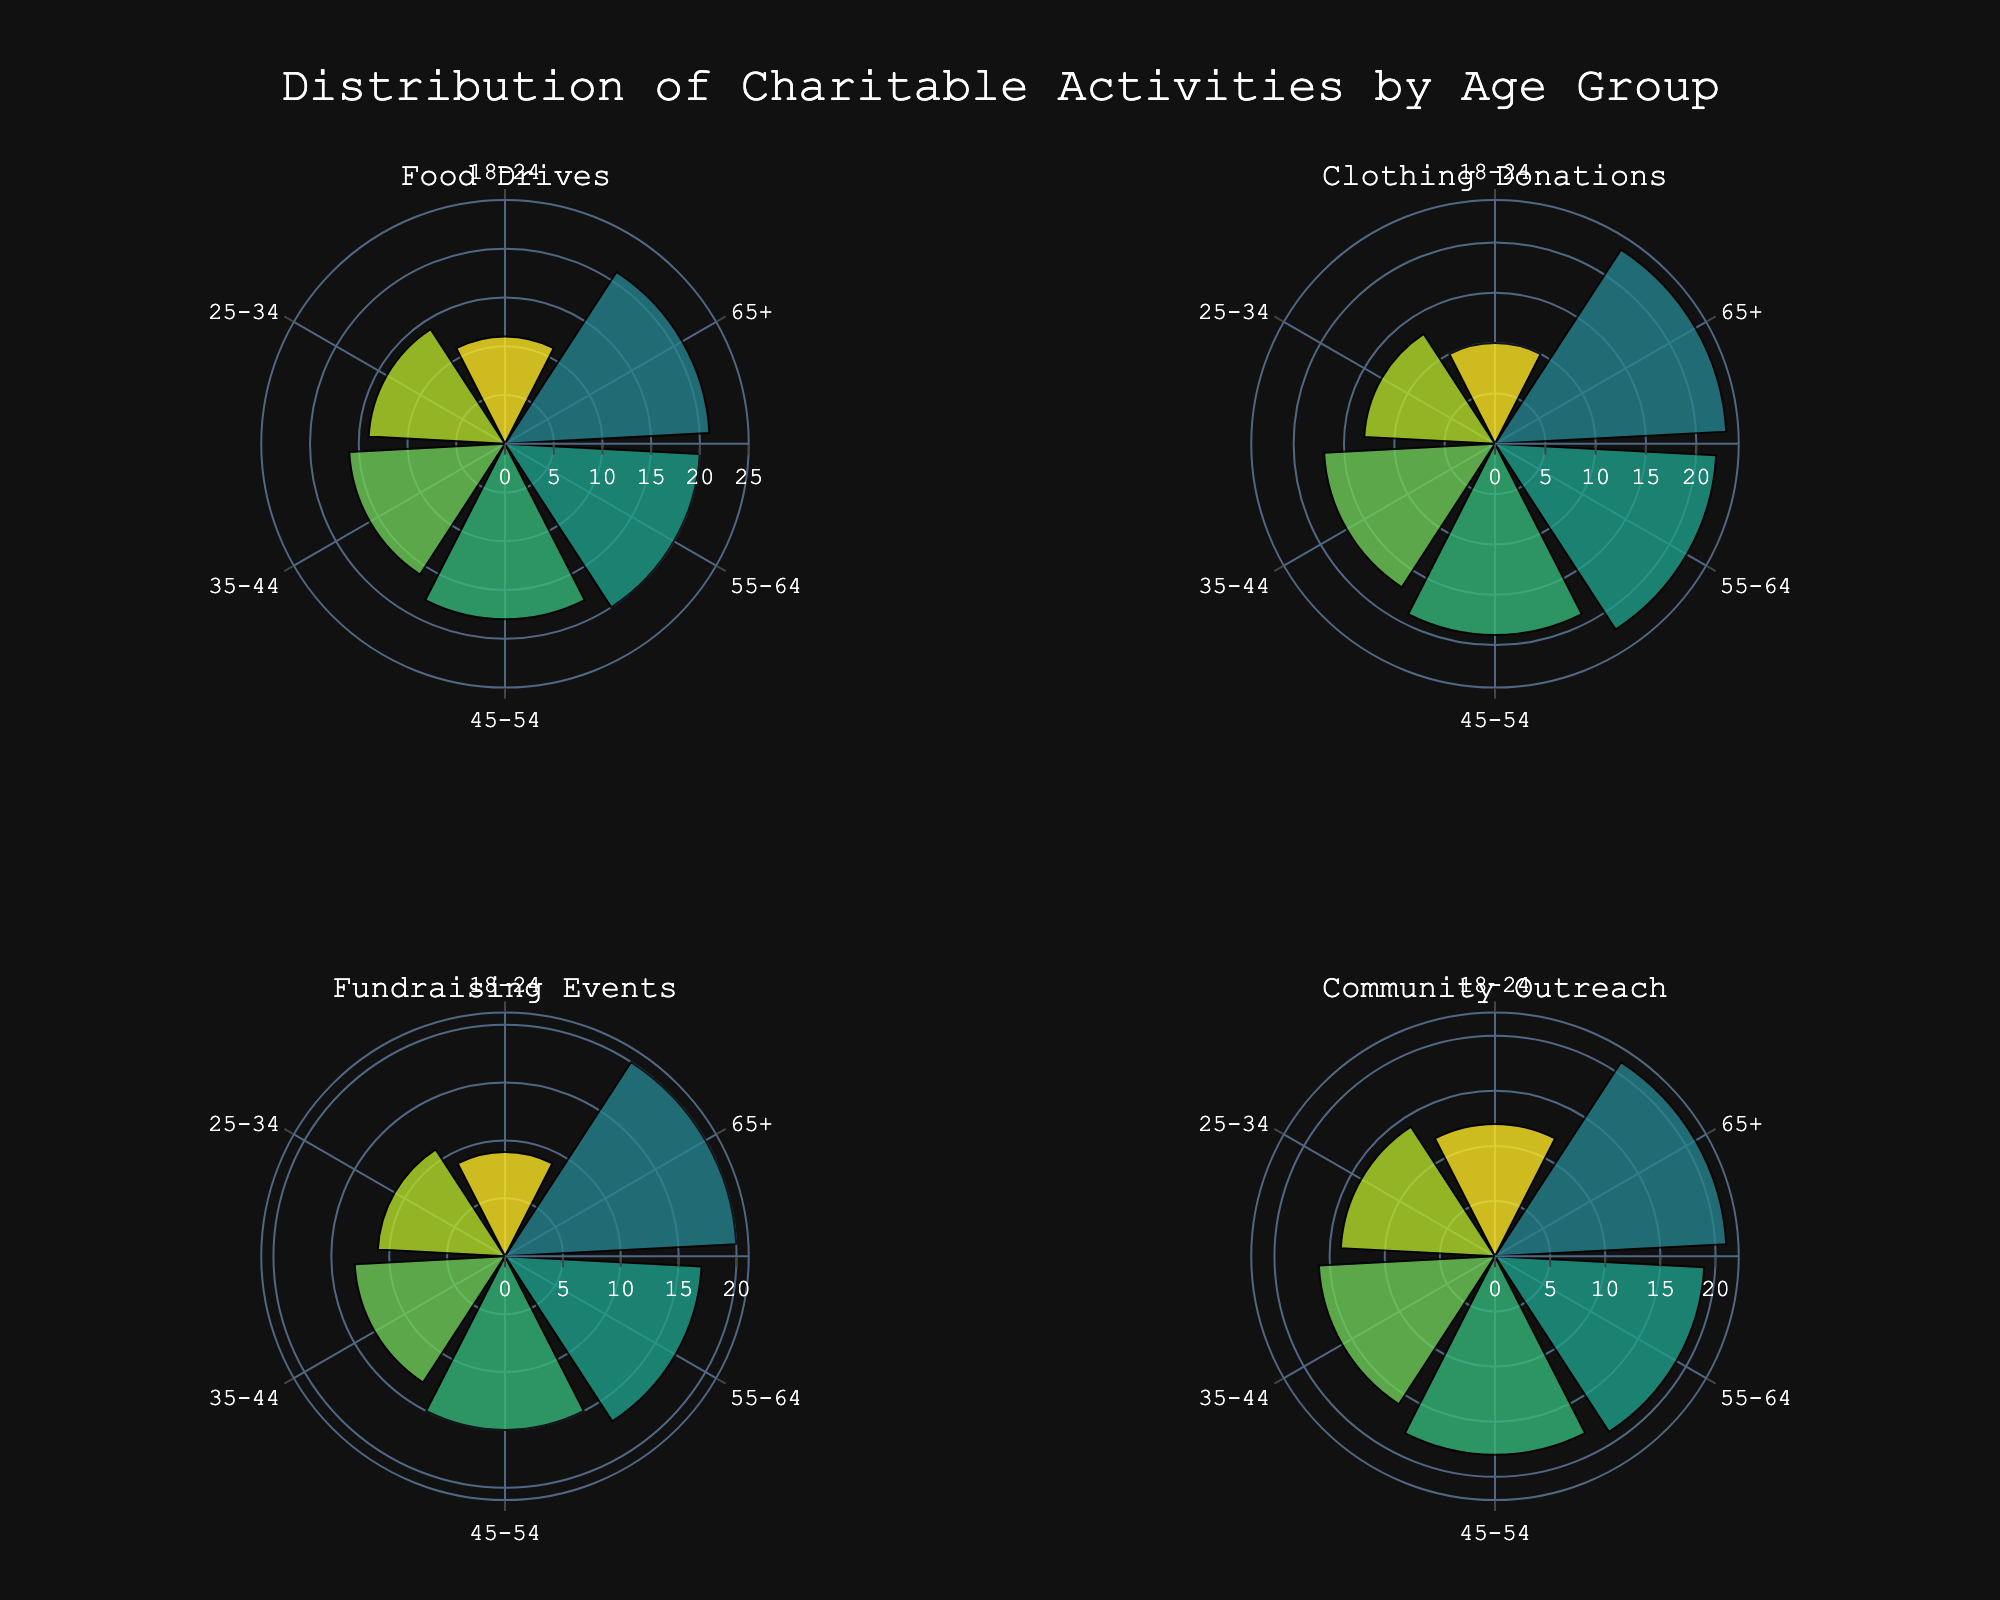what is the title of the figure? The title is displayed at the top center of the figure. It reads, "Distribution of Charitable Activities by Age Group."
Answer: Distribution of Charitable Activities by Age Group how many categories of charitable activities are depicted in the chart? There are four subplot titles, each representing a different category of charitable activities within the chart: Food Drives, Clothing Donations, Fundraising Events, and Community Outreach.
Answer: Four which age group has the highest participation percentage in Food Drives? In the subplot for Food Drives, the bar showing the highest percentage corresponds to the 65+ age group, which has the highest value.
Answer: 65+ what is the range of percentages in the radial axis of the plots? The radial axis, which shows the values of percentages, ranges from 0 to 25.
Answer: 0 to 25 compare the participation percentage of 18-24 age group in Clothing Donations and Fundraising Events. In the Clothing Donations subplot, the 18-24 age group's participation is at 10%, while in the Fundraising Events subplot, it is at 9%. Thus, more 18-24 age group members participate in Clothing Donations compared to Fundraising Events.
Answer: Clothing Donations has 10%, Fundraising Events has 9% what is the average participation percentage of the 45-54 age group across all four categories? To find the average, sum the percentages: 18% (Food Drives) + 19% (Clothing Donations) + 15% (Fundraising Events) + 18% (Community Outreach) = 70%. Then, divide by the number of categories, which is 4: 70 / 4 = 17.5%.
Answer: 17.5% which age group shows the most variation in participation percentages across different categories? Calculate the difference between the highest and lowest percentages for each age group across all categories. The 18-24 age group varies from 9% (Fundraising Events) to 12% (Community Outreach), a 3% difference. The 25-34 ranges from 11% to 14% (3%). The 35-44 ranges from 13% to 17% (4%). The 45-54 ranges from 15% to 19% (4%). The 55-64 ranges from 17% to 22% (5%). The 65+ ranges from 20% to 23% (3%). The 55-64 age group, therefore, shows the most variation.
Answer: 55-64 age group is there consistent growth in participation percentages with increasing age for any category? Reviewing each age group's trend in all categories shows that the participation percentage consistently increases with age in Food Drives and Clothing Donations categories across all age groups.
Answer: Yes, in Food Drives and Clothing Donations identify the category with the least overall variation in participation percentages among all age groups. Calculate the difference between the highest and lowest percentage within each category: Food Drives ranges from 11% to 21% (10%). Clothing Donations ranges from 10% to 23% (13%). Fundraising Events ranges from 9% to 20% (11%). Community Outreach ranges from 12% to 21% (9%). The Community Outreach category exhibits the least overall variation, from 12% to 21%.
Answer: Community Outreach 